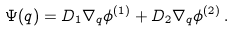Convert formula to latex. <formula><loc_0><loc_0><loc_500><loc_500>\Psi ( q ) = D _ { 1 } \nabla _ { q } \phi ^ { ( 1 ) } + D _ { 2 } \nabla _ { q } \phi ^ { ( 2 ) } \, .</formula> 